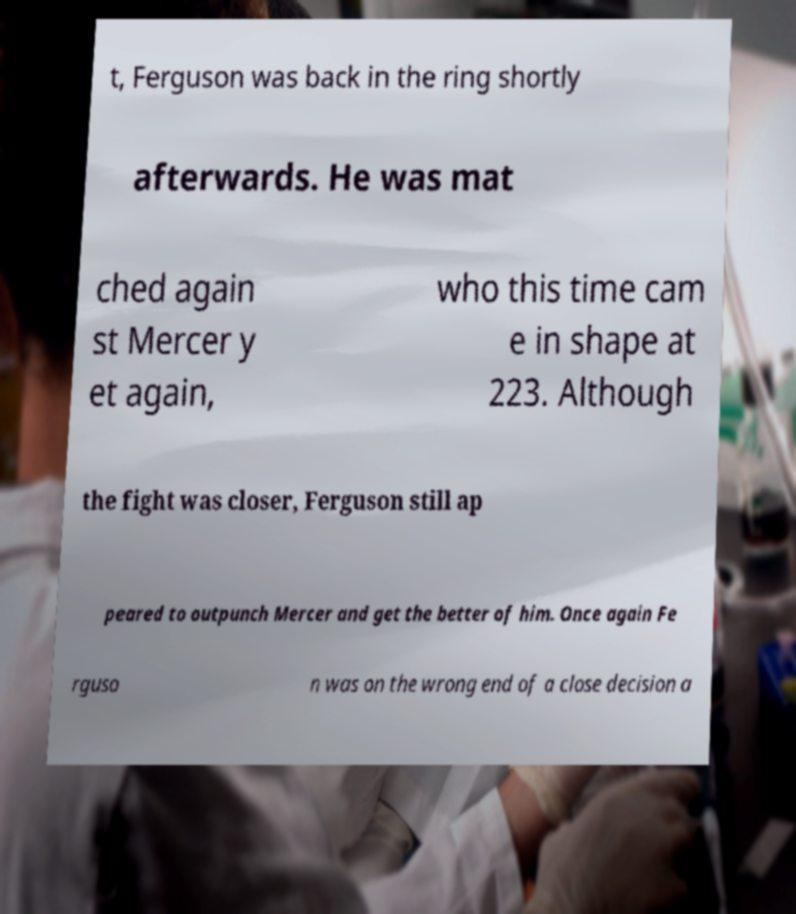There's text embedded in this image that I need extracted. Can you transcribe it verbatim? t, Ferguson was back in the ring shortly afterwards. He was mat ched again st Mercer y et again, who this time cam e in shape at 223. Although the fight was closer, Ferguson still ap peared to outpunch Mercer and get the better of him. Once again Fe rguso n was on the wrong end of a close decision a 